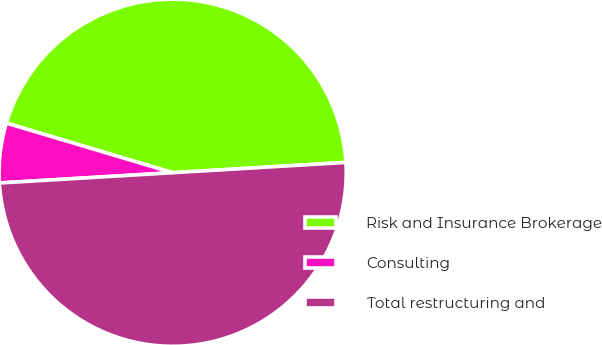<chart> <loc_0><loc_0><loc_500><loc_500><pie_chart><fcel>Risk and Insurance Brokerage<fcel>Consulting<fcel>Total restructuring and<nl><fcel>44.44%<fcel>5.56%<fcel>50.0%<nl></chart> 